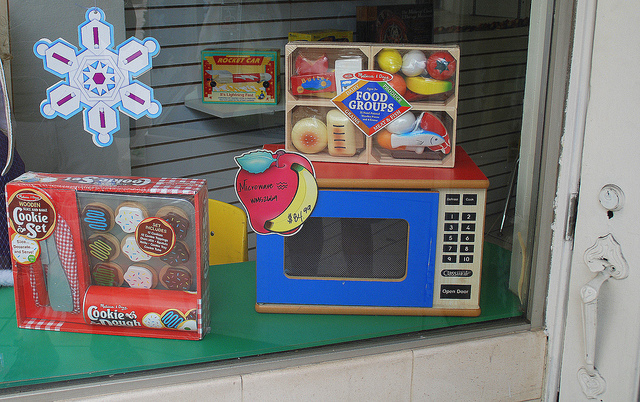<image>What kind of rack  is above the stove? It is ambiguous what kind of rack is above the stove. It can be a display, food, or spice rack. What kind of rack  is above the stove? I am not sure what kind of rack is above the stove. It can be a food rack, display rack, play food rack, shelf, or spice rack. 